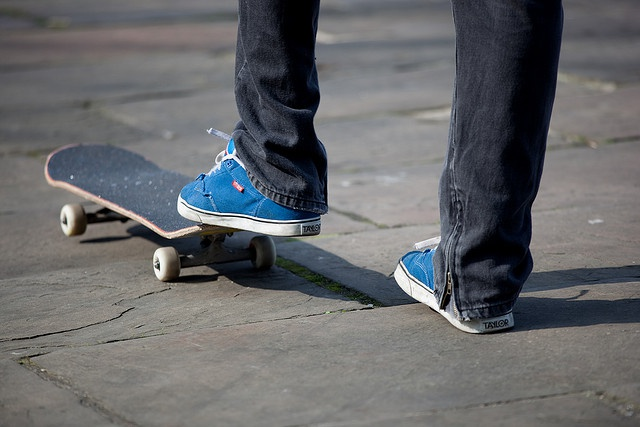Describe the objects in this image and their specific colors. I can see people in gray, black, and lightgray tones and skateboard in gray, black, and lightgray tones in this image. 